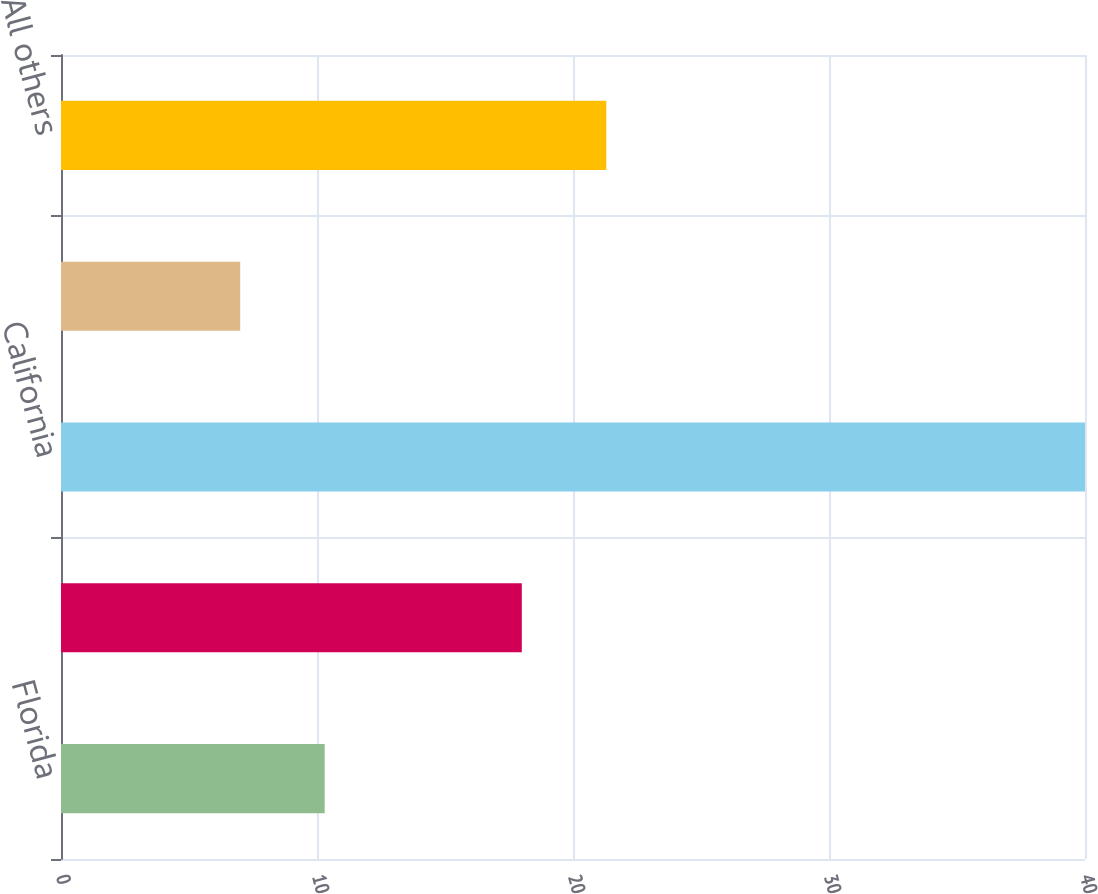Convert chart. <chart><loc_0><loc_0><loc_500><loc_500><bar_chart><fcel>Florida<fcel>New York<fcel>California<fcel>Wisconsin<fcel>All others<nl><fcel>10.3<fcel>18<fcel>40<fcel>7<fcel>21.3<nl></chart> 